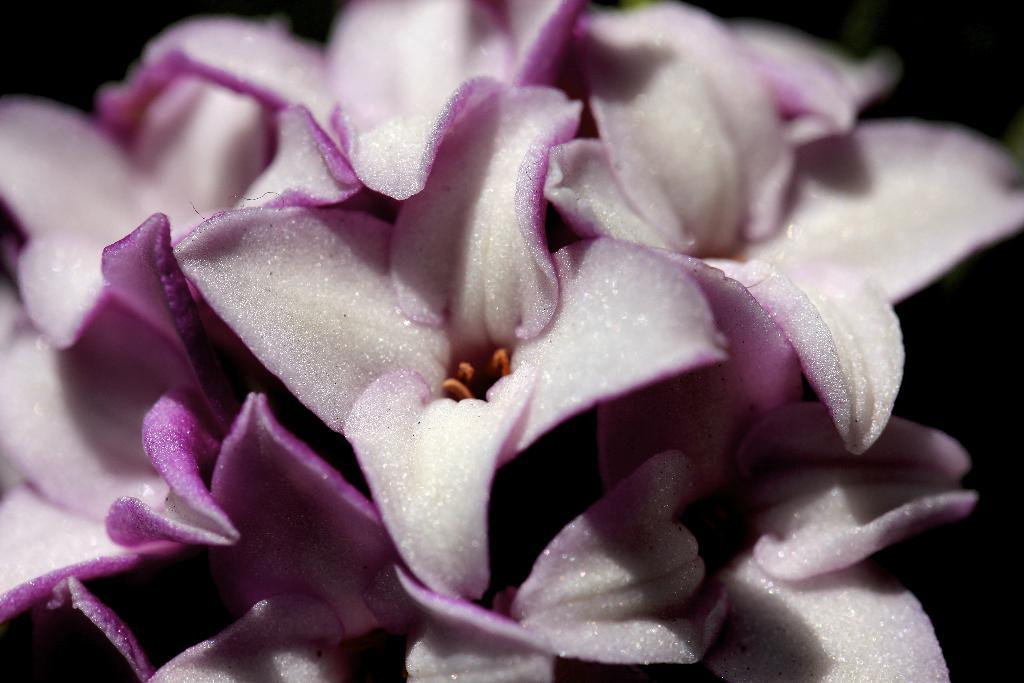What type of living organisms can be seen in the image? There are flowers in the image. What colors are the flowers in the image? The flowers are white and pink in color. What type of operation is being performed on the flowers in the image? There is no operation being performed on the flowers in the image; they are simply growing and blooming. 